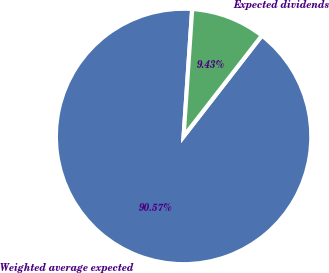Convert chart. <chart><loc_0><loc_0><loc_500><loc_500><pie_chart><fcel>Weighted average expected<fcel>Expected dividends<nl><fcel>90.57%<fcel>9.43%<nl></chart> 